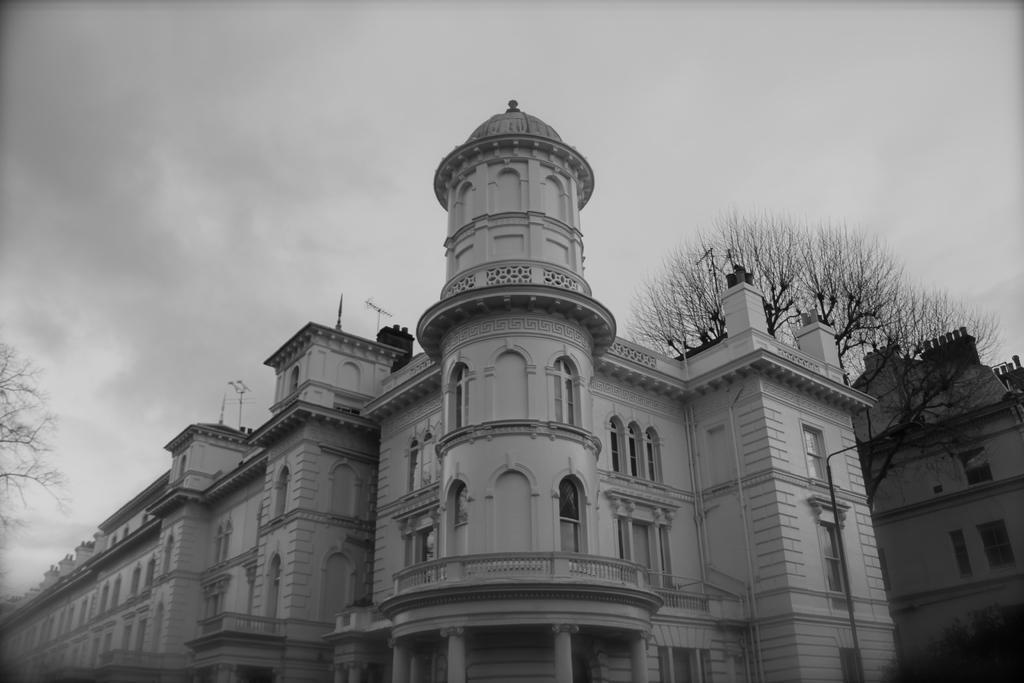In one or two sentences, can you explain what this image depicts? In this picture we can see few buildings, trees and clouds, it is a black and white photography. 